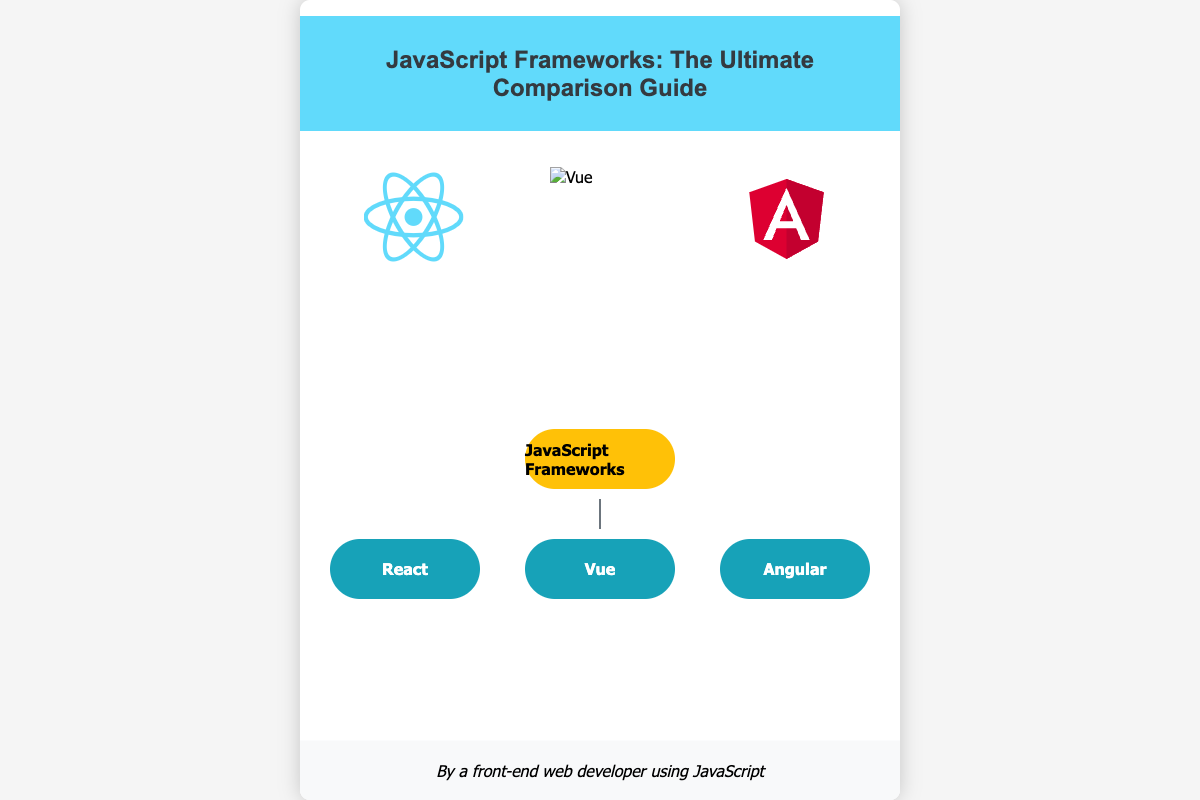What is the title of the book? The title of the book is prominently displayed at the top of the cover.
Answer: JavaScript Frameworks: The Ultimate Comparison Guide Who is the author of the book? The author's name is stated at the bottom of the cover.
Answer: By a front-end web developer using JavaScript What color is the background of the book cover? The background color of the book cover is observed in the style section of the document.
Answer: White Which frameworks are featured on the cover? The frameworks are represented by icons on the cover.
Answer: React, Vue, Angular What shape are the nodes in the flowchart? The appearance of the nodes is described in the styling of the flowchart section.
Answer: Rounded What is the main theme depicted on the cover? The visuals and text on the cover focus on comparing JavaScript frameworks.
Answer: Comparison of JavaScript frameworks What is the color of the start node in the flowchart? The start node's color is specified in the style section of the document.
Answer: Yellow How many framework icons are there? The number of icons is evident from the icons displayed in the framework section.
Answer: Three What visual feature connects the nodes in the flowchart? The connection between nodes is described in the styling of the flowchart.
Answer: Edges 